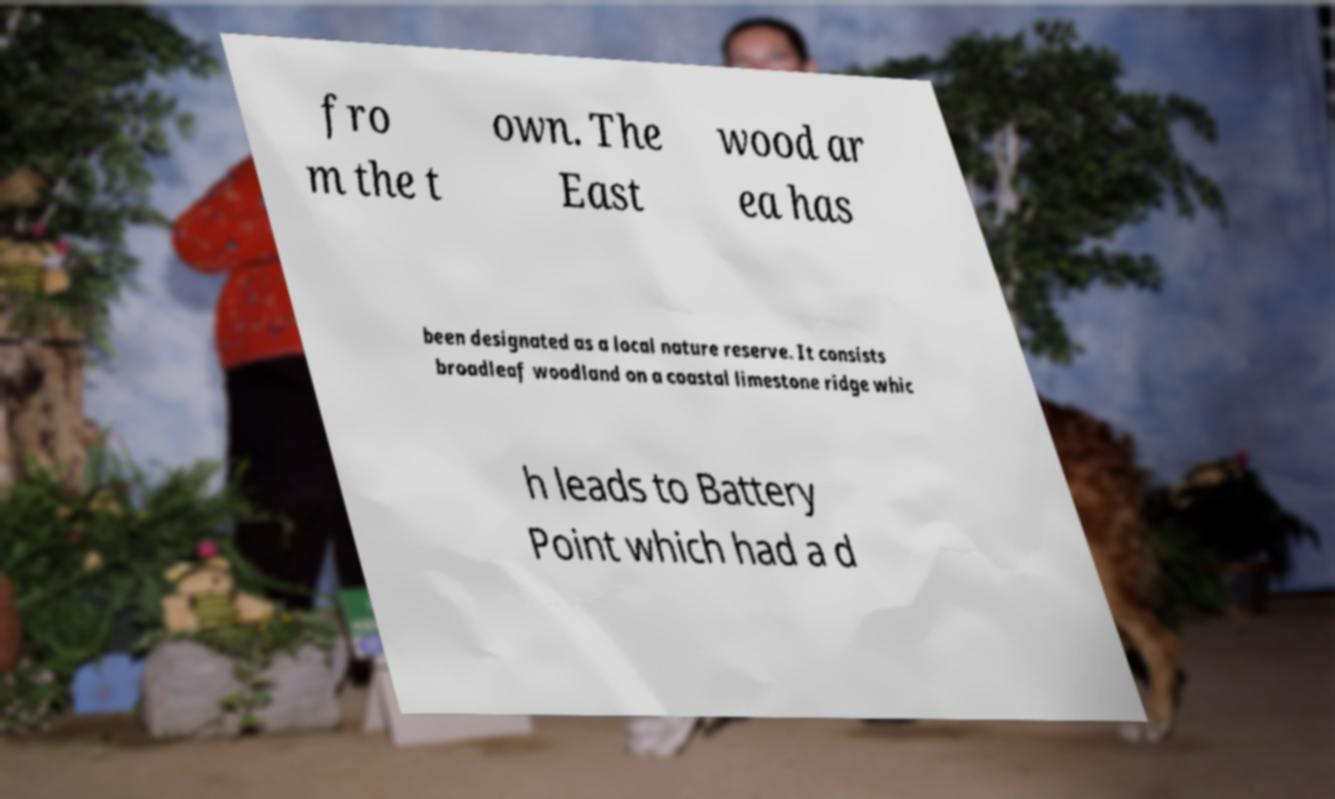Please identify and transcribe the text found in this image. fro m the t own. The East wood ar ea has been designated as a local nature reserve. It consists broadleaf woodland on a coastal limestone ridge whic h leads to Battery Point which had a d 